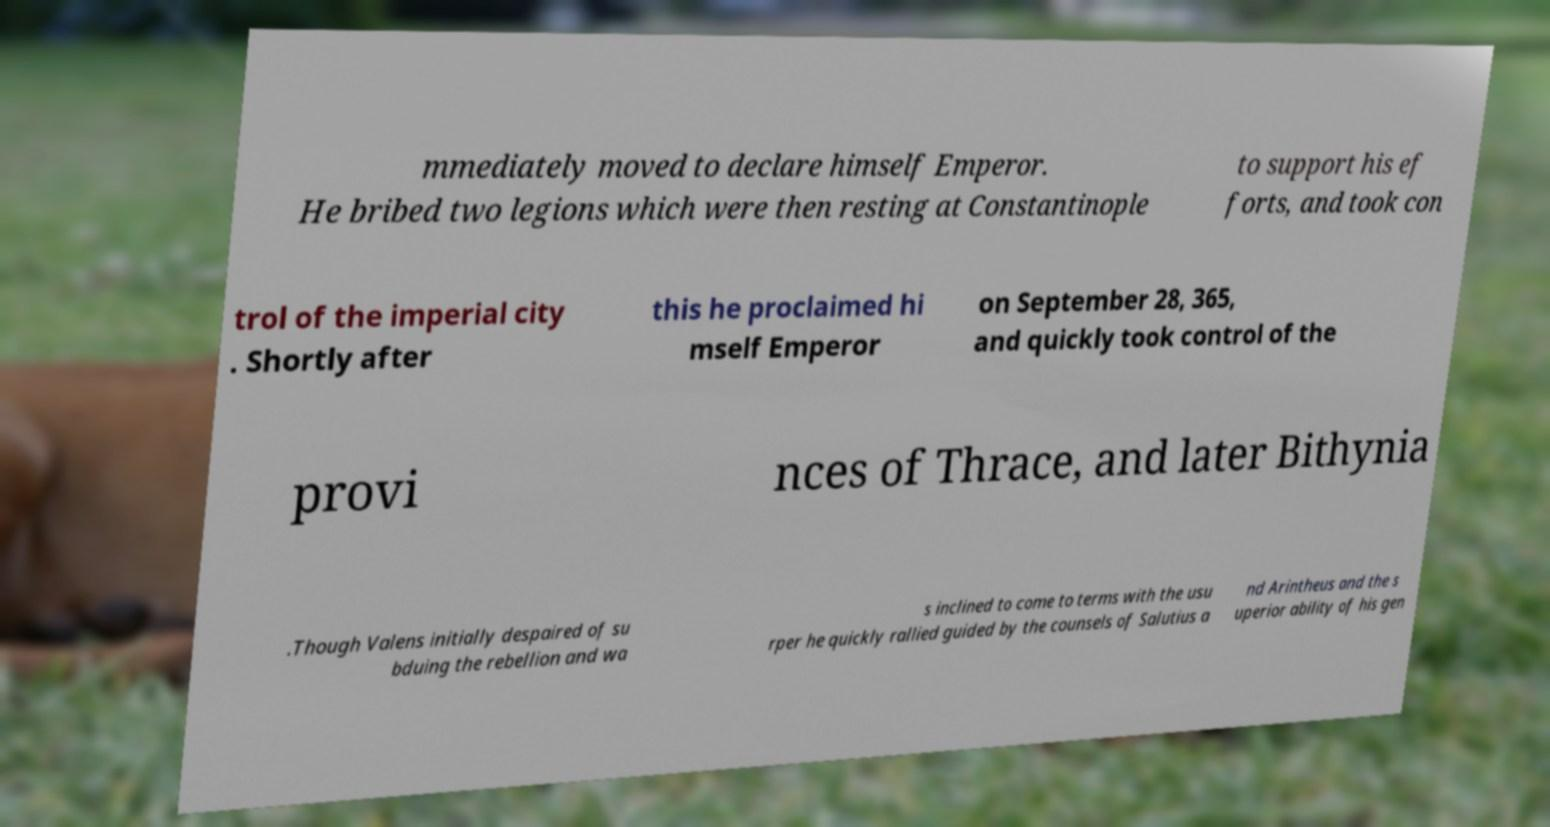There's text embedded in this image that I need extracted. Can you transcribe it verbatim? mmediately moved to declare himself Emperor. He bribed two legions which were then resting at Constantinople to support his ef forts, and took con trol of the imperial city . Shortly after this he proclaimed hi mself Emperor on September 28, 365, and quickly took control of the provi nces of Thrace, and later Bithynia .Though Valens initially despaired of su bduing the rebellion and wa s inclined to come to terms with the usu rper he quickly rallied guided by the counsels of Salutius a nd Arintheus and the s uperior ability of his gen 